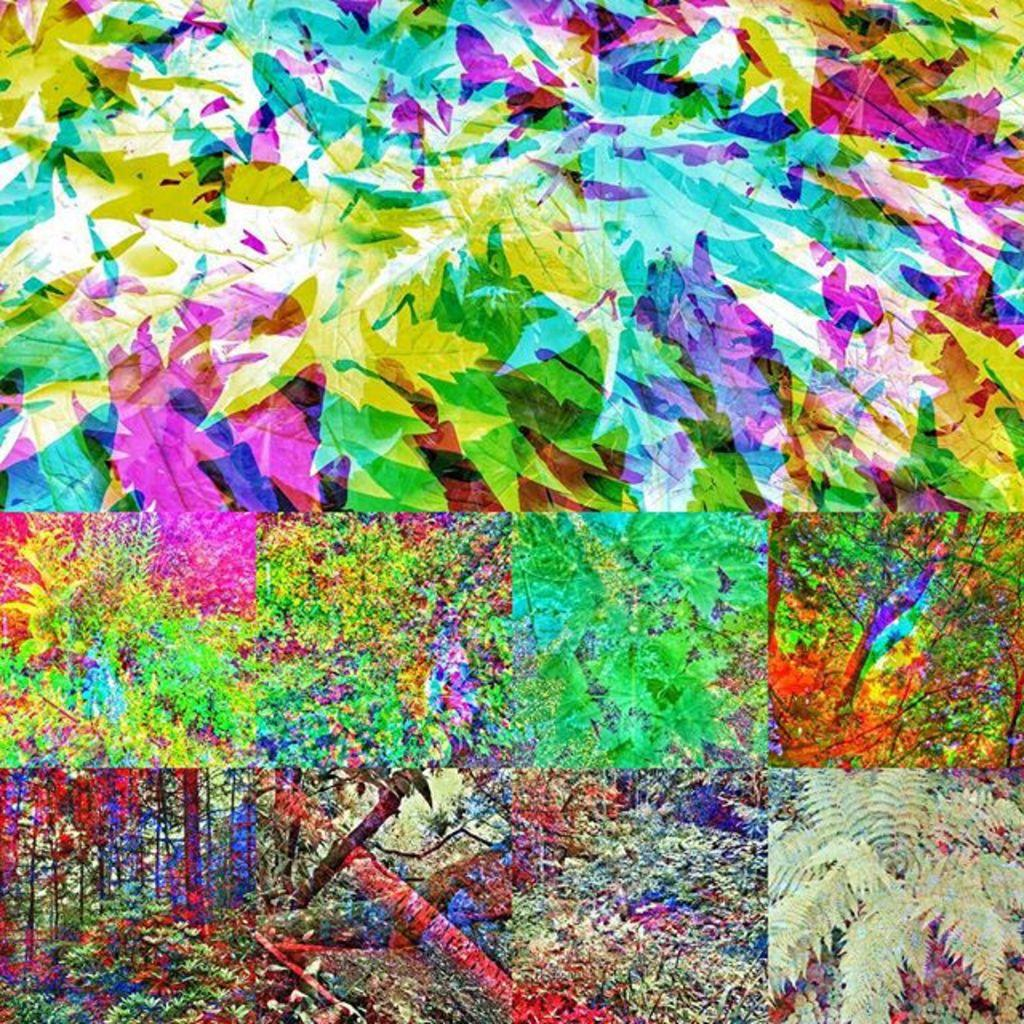What type of artwork is the image? The image is a collage. What can be seen among the various elements in the collage? There are colorful leaves and trees in the image. What type of net is used to catch the leaves in the image? There is no net present in the image; it is a collage featuring colorful leaves and trees. 